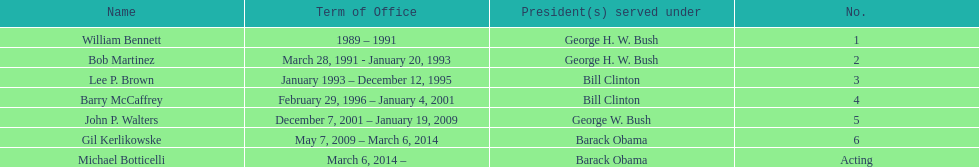For how long was the first director in office? 2 years. 